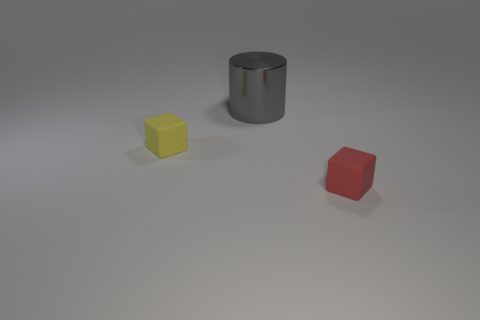How many things are small yellow objects or large cubes?
Make the answer very short. 1. Are there any other gray shiny things that have the same shape as the large gray object?
Your answer should be compact. No. How many tiny cubes are right of the tiny yellow matte cube?
Make the answer very short. 1. There is a small cube that is to the left of the rubber block that is on the right side of the big gray cylinder; what is its material?
Ensure brevity in your answer.  Rubber. There is another object that is the same size as the red object; what material is it?
Offer a very short reply. Rubber. Is there a brown rubber block that has the same size as the yellow object?
Your answer should be compact. No. There is a tiny block to the left of the red cube; what color is it?
Offer a very short reply. Yellow. There is a small matte cube that is to the right of the large thing; is there a red cube that is to the right of it?
Your answer should be compact. No. How many other things are there of the same color as the big cylinder?
Provide a succinct answer. 0. Is the size of the cube on the right side of the yellow object the same as the thing that is to the left of the gray shiny cylinder?
Your response must be concise. Yes. 